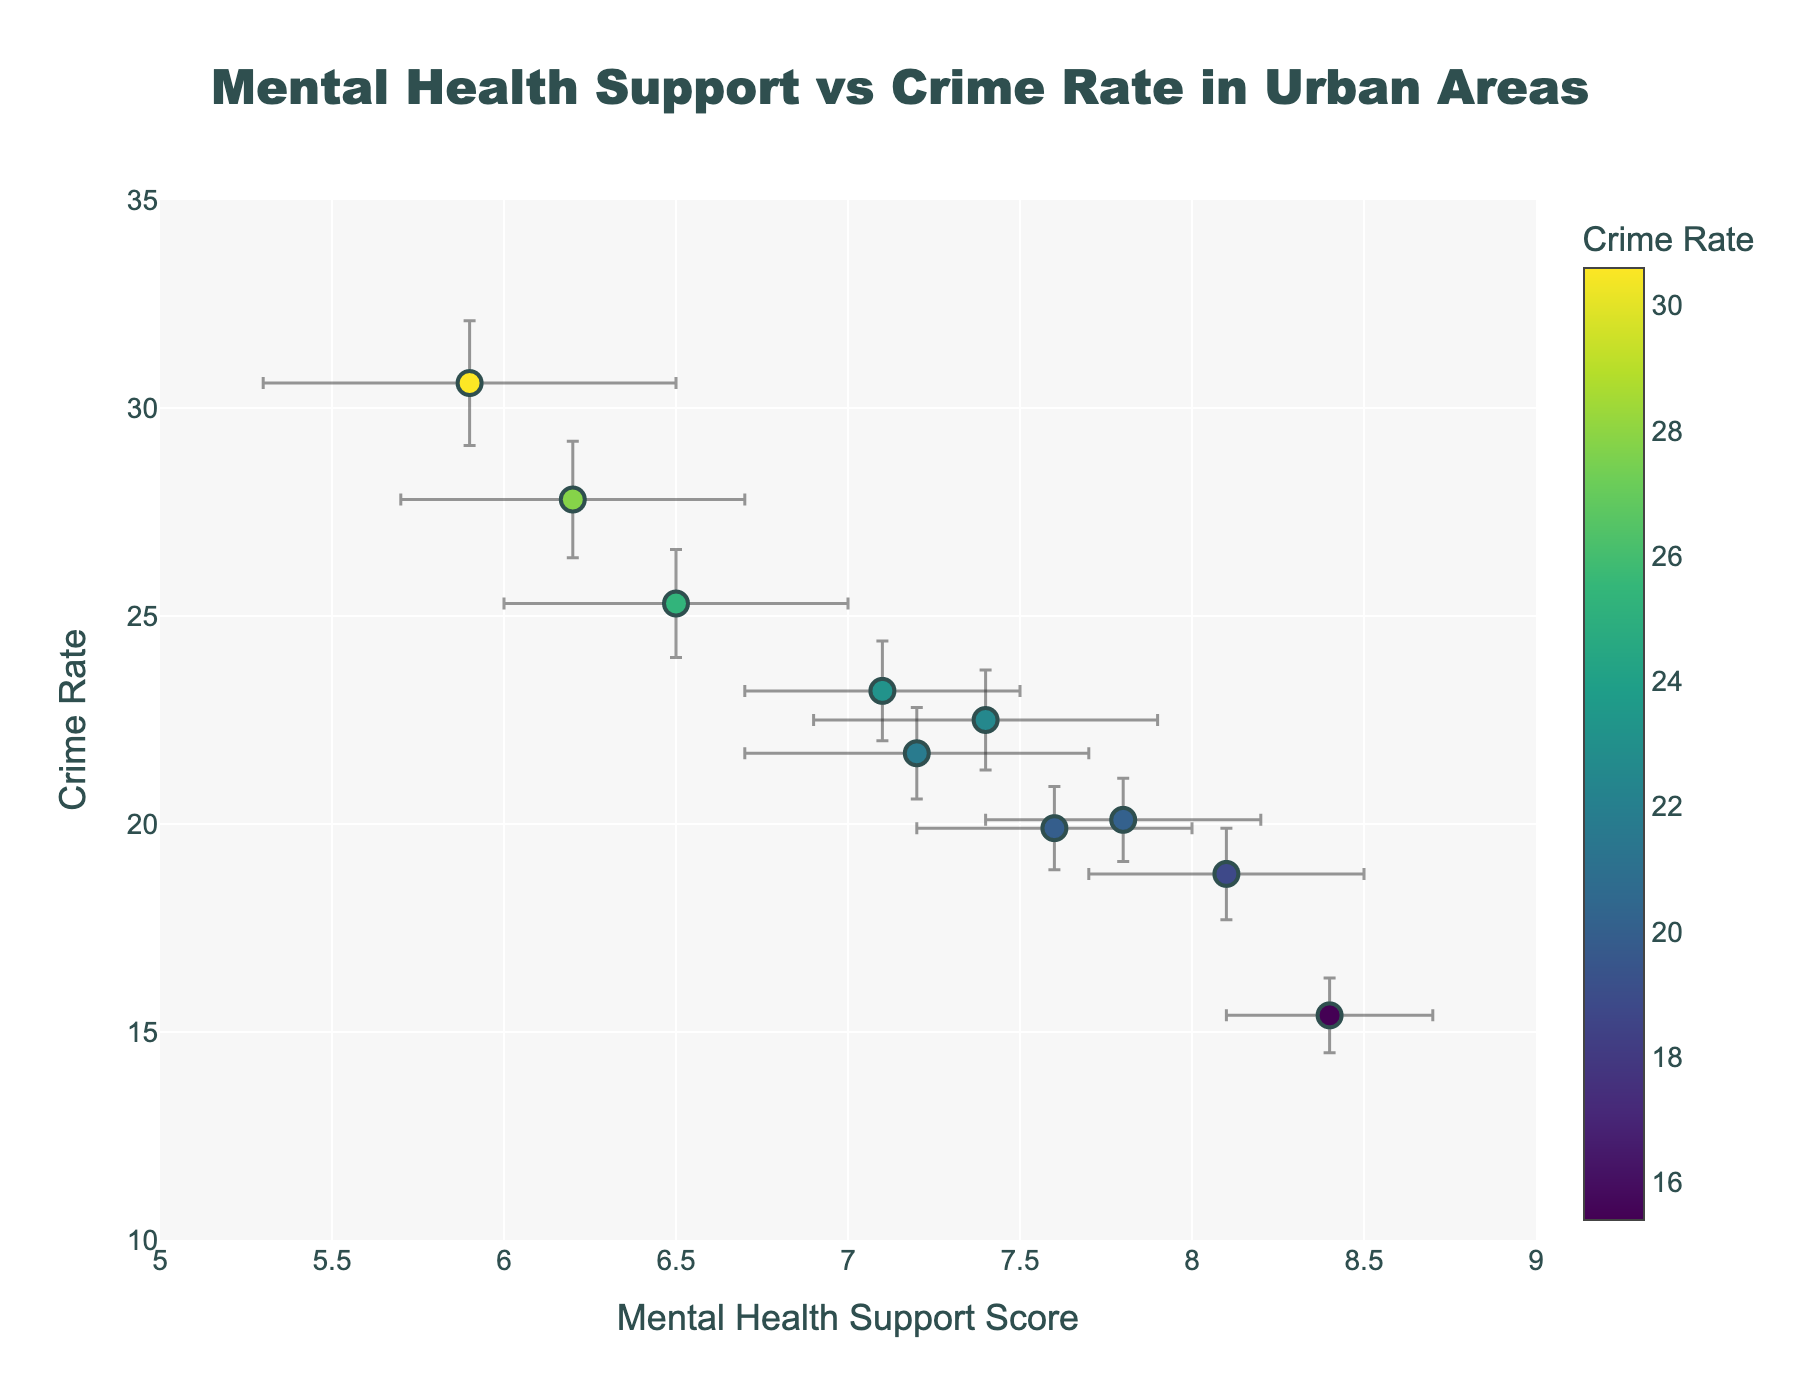How many urban areas are displayed in the plot? Count the number of markers on the plot, which correspond to the number of urban areas represented.
Answer: 10 Which urban area has the highest crime rate, and what is the value? Identify the data point with the highest y-axis value, which represents the crime rate. The location text of this data point provides the urban area's name.
Answer: Chicago, 30.6 What is the relationship between the crime rate and mental health support score for Phoenix? Locate Phoenix on the plot and identify its x and y-axis values to understand their relationship.
Answer: As Mental Health Support Score increases to 8.4, Crime Rate decreases to 15.4 How much larger is the crime rate in Chicago compared to Phoenix? Subtract the crime rate of Phoenix from the crime rate of Chicago.
Answer: 30.6 - 15.4 = 15.2 Do any urban areas have the same mental health support score? If so, which ones and what is the score? Look for overlapping x-axis values on the mental health support score axis.
Answer: No urban areas have the same mental health support score Which urban area has the smallest error bar for crime rate data? Identify the marker with the smallest vertical error bar, corresponding to the smallest Error_Crime_Rate value.
Answer: Philadelphia Is there any correlation between mental health support score and crime rate across these urban areas? Observe the general trend of the markers. A visual inspection of the plot should reveal if there is an upward or downward trend.
Answer: There appears to be a negative correlation; as mental health support score increases, crime rate generally decreases What is the average crime rate across all the urban areas? Add up all the crime rate values and divide by the number of urban areas.
Answer: (22.5 + 18.8 + 30.6 + 25.3 + 20.1 + 15.4 + 27.8 + 23.2 + 19.9 + 21.7) / 10 = 22.53 